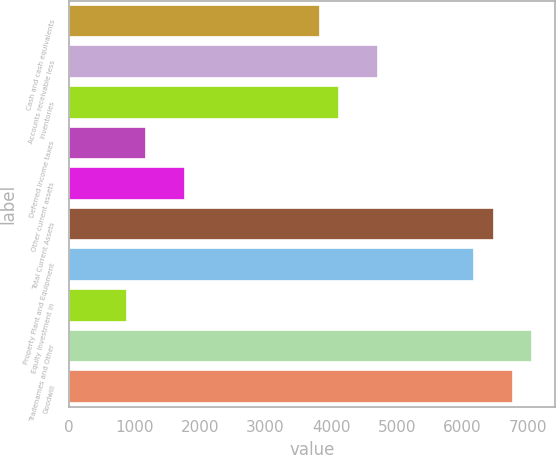<chart> <loc_0><loc_0><loc_500><loc_500><bar_chart><fcel>Cash and cash equivalents<fcel>Accounts receivable less<fcel>Inventories<fcel>Deferred income taxes<fcel>Other current assets<fcel>Total Current Assets<fcel>Property Plant and Equipment<fcel>Equity Investment in<fcel>Tradenames and Other<fcel>Goodwill<nl><fcel>3828.7<fcel>4712.2<fcel>4123.2<fcel>1178.2<fcel>1767.2<fcel>6479.2<fcel>6184.7<fcel>883.7<fcel>7068.2<fcel>6773.7<nl></chart> 